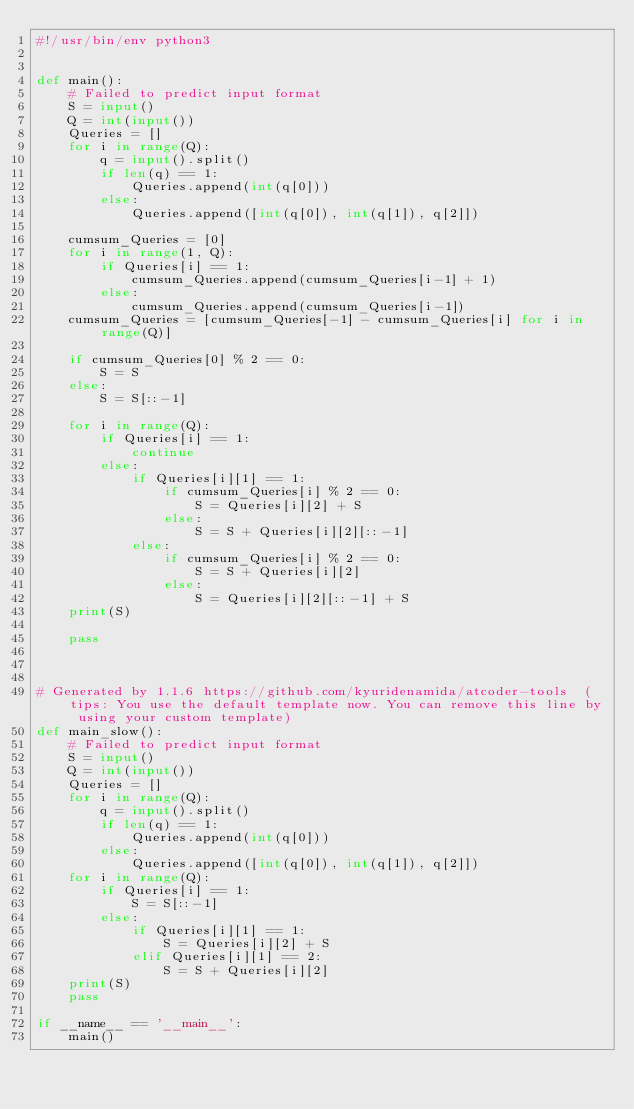<code> <loc_0><loc_0><loc_500><loc_500><_Python_>#!/usr/bin/env python3


def main():
    # Failed to predict input format
    S = input()
    Q = int(input())
    Queries = []
    for i in range(Q):
        q = input().split()
        if len(q) == 1:
            Queries.append(int(q[0]))
        else:
            Queries.append([int(q[0]), int(q[1]), q[2]])

    cumsum_Queries = [0]
    for i in range(1, Q):
        if Queries[i] == 1:
            cumsum_Queries.append(cumsum_Queries[i-1] + 1)
        else:
            cumsum_Queries.append(cumsum_Queries[i-1])
    cumsum_Queries = [cumsum_Queries[-1] - cumsum_Queries[i] for i in range(Q)]

    if cumsum_Queries[0] % 2 == 0:
        S = S
    else:
        S = S[::-1]

    for i in range(Q):
        if Queries[i] == 1:
            continue
        else:
            if Queries[i][1] == 1:
                if cumsum_Queries[i] % 2 == 0:
                    S = Queries[i][2] + S
                else:
                    S = S + Queries[i][2][::-1]
            else:
                if cumsum_Queries[i] % 2 == 0:
                    S = S + Queries[i][2]
                else:
                    S = Queries[i][2][::-1] + S
    print(S)

    pass



# Generated by 1.1.6 https://github.com/kyuridenamida/atcoder-tools  (tips: You use the default template now. You can remove this line by using your custom template)
def main_slow():
    # Failed to predict input format
    S = input()
    Q = int(input())
    Queries = []
    for i in range(Q):
        q = input().split()
        if len(q) == 1:
            Queries.append(int(q[0]))
        else:
            Queries.append([int(q[0]), int(q[1]), q[2]])
    for i in range(Q):
        if Queries[i] == 1:
            S = S[::-1]
        else:
            if Queries[i][1] == 1:
                S = Queries[i][2] + S
            elif Queries[i][1] == 2:
                S = S + Queries[i][2]
    print(S)
    pass

if __name__ == '__main__':
    main()
</code> 